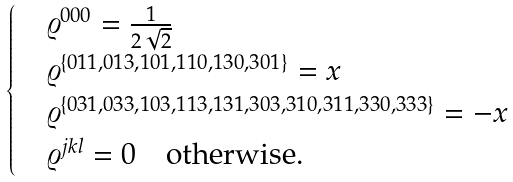<formula> <loc_0><loc_0><loc_500><loc_500>\begin{cases} & \varrho ^ { 0 0 0 } = \frac { 1 } { 2 \sqrt { 2 } } \\ & \varrho ^ { \{ 0 1 1 , 0 1 3 , 1 0 1 , 1 1 0 , 1 3 0 , 3 0 1 \} } = x \\ & \varrho ^ { \{ 0 3 1 , 0 3 3 , 1 0 3 , 1 1 3 , 1 3 1 , 3 0 3 , 3 1 0 , 3 1 1 , 3 3 0 , 3 3 3 \} } = - x \\ & \varrho ^ { j k l } = 0 \quad \text {otherwise} . \\ \end{cases}</formula> 